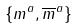Convert formula to latex. <formula><loc_0><loc_0><loc_500><loc_500>\{ m ^ { a } , \overline { m } ^ { a } \}</formula> 